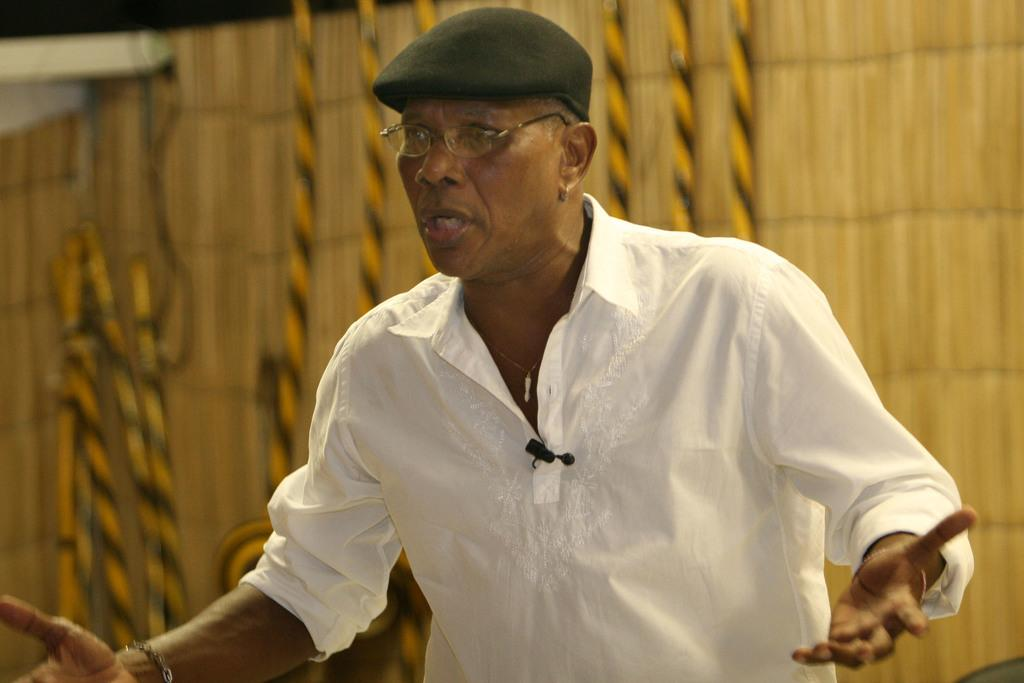Who is present in the image? There is a person in the image. What is the person wearing on their head? The person is wearing a cap. What is the person wearing on their body? The person is wearing a white dress. What accessory is the person wearing on their face? The person is wearing spectacles. What disease is the person trying to cure by rubbing the good-bye charm in the image? There is no mention of a disease, rubbing, or good-bye charm in the image. 